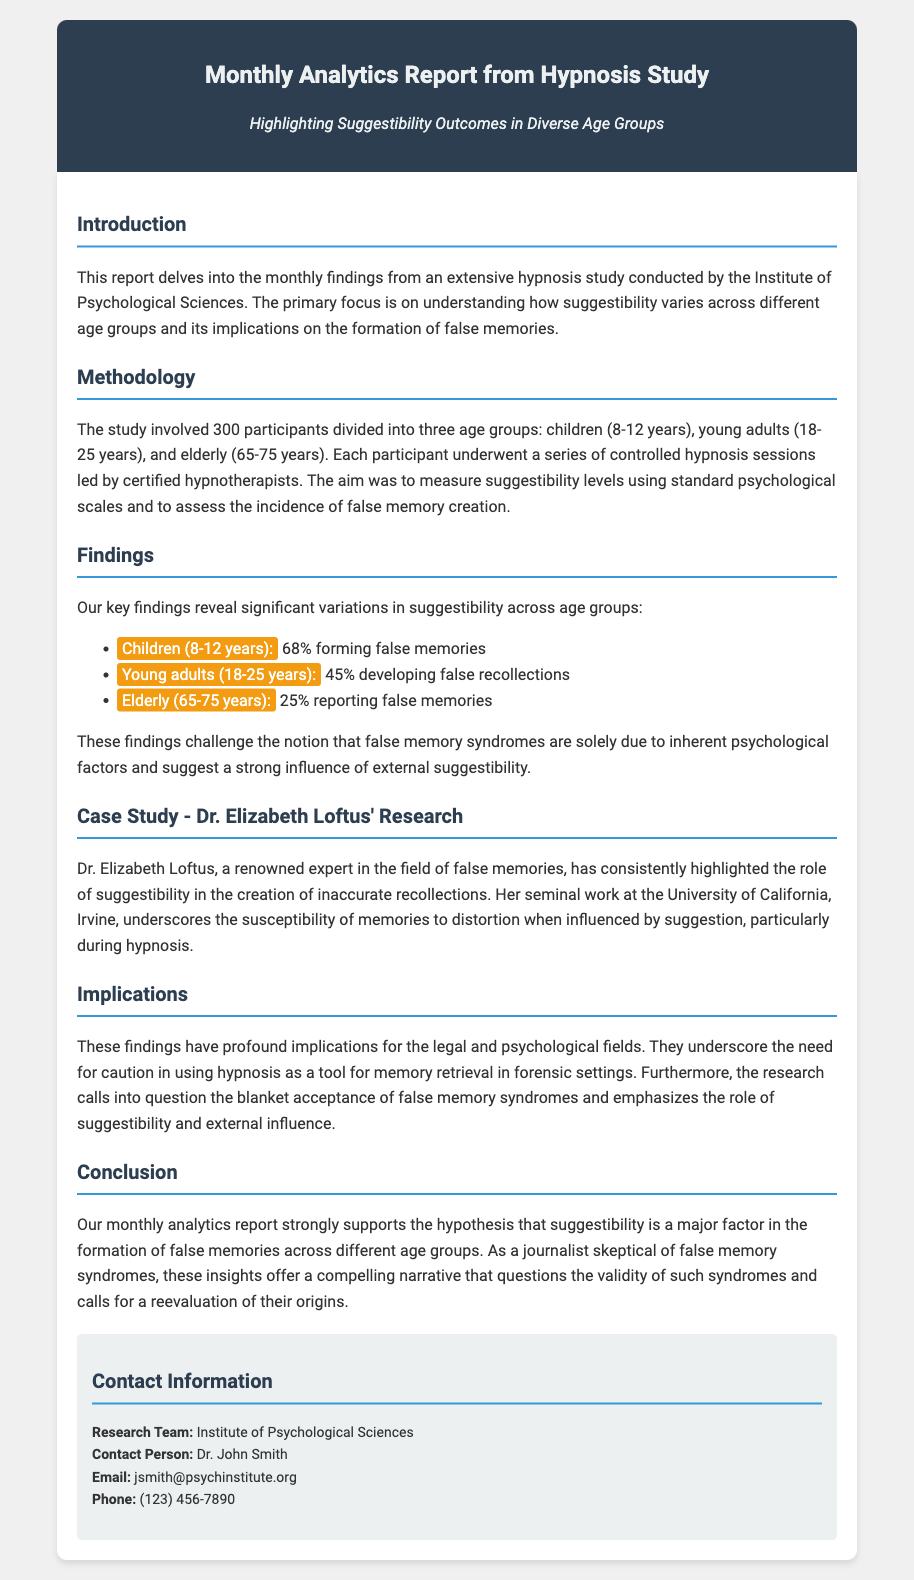What is the purpose of the report? The report delves into the monthly findings from an extensive hypnosis study, focusing on suggestibility across different age groups.
Answer: Understanding suggestibility How many participants were involved in the study? The study involved a total of 300 participants divided into three age groups.
Answer: 300 participants What percentage of children formed false memories? The key finding states that 68% of children (8-12 years) formed false memories.
Answer: 68% Who is the renowned expert mentioned in the report? The report highlights Dr. Elizabeth Loftus as a renowned expert in the field of false memories.
Answer: Dr. Elizabeth Loftus What age group reported the lowest incidence of false memories? The elderly group (65-75 years) reported the lowest incidence at 25%.
Answer: Elderly (65-75 years) What implication does the report suggest for the legal field? The findings underscore the need for caution in using hypnosis as a tool for memory retrieval in forensic settings.
Answer: Caution in forensic settings What is the report's suggestion regarding false memory syndromes? The research calls into question the blanket acceptance of false memory syndromes.
Answer: Calls into question What is the contact email for Dr. John Smith? The contact email provided for Dr. John Smith is mentioned in the contact information section.
Answer: jsmith@psychinstitute.org What was measured during the hypnosis sessions? The aim was to measure suggestibility levels using standard psychological scales.
Answer: Suggestibility levels 